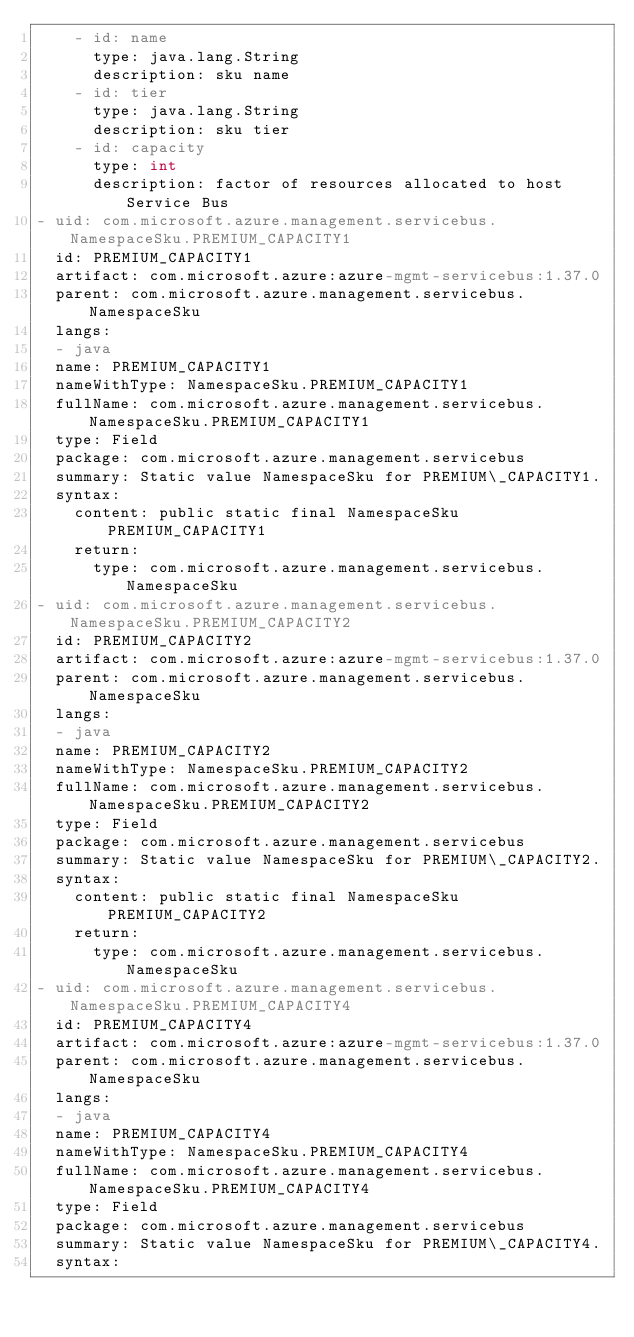Convert code to text. <code><loc_0><loc_0><loc_500><loc_500><_YAML_>    - id: name
      type: java.lang.String
      description: sku name
    - id: tier
      type: java.lang.String
      description: sku tier
    - id: capacity
      type: int
      description: factor of resources allocated to host Service Bus
- uid: com.microsoft.azure.management.servicebus.NamespaceSku.PREMIUM_CAPACITY1
  id: PREMIUM_CAPACITY1
  artifact: com.microsoft.azure:azure-mgmt-servicebus:1.37.0
  parent: com.microsoft.azure.management.servicebus.NamespaceSku
  langs:
  - java
  name: PREMIUM_CAPACITY1
  nameWithType: NamespaceSku.PREMIUM_CAPACITY1
  fullName: com.microsoft.azure.management.servicebus.NamespaceSku.PREMIUM_CAPACITY1
  type: Field
  package: com.microsoft.azure.management.servicebus
  summary: Static value NamespaceSku for PREMIUM\_CAPACITY1.
  syntax:
    content: public static final NamespaceSku PREMIUM_CAPACITY1
    return:
      type: com.microsoft.azure.management.servicebus.NamespaceSku
- uid: com.microsoft.azure.management.servicebus.NamespaceSku.PREMIUM_CAPACITY2
  id: PREMIUM_CAPACITY2
  artifact: com.microsoft.azure:azure-mgmt-servicebus:1.37.0
  parent: com.microsoft.azure.management.servicebus.NamespaceSku
  langs:
  - java
  name: PREMIUM_CAPACITY2
  nameWithType: NamespaceSku.PREMIUM_CAPACITY2
  fullName: com.microsoft.azure.management.servicebus.NamespaceSku.PREMIUM_CAPACITY2
  type: Field
  package: com.microsoft.azure.management.servicebus
  summary: Static value NamespaceSku for PREMIUM\_CAPACITY2.
  syntax:
    content: public static final NamespaceSku PREMIUM_CAPACITY2
    return:
      type: com.microsoft.azure.management.servicebus.NamespaceSku
- uid: com.microsoft.azure.management.servicebus.NamespaceSku.PREMIUM_CAPACITY4
  id: PREMIUM_CAPACITY4
  artifact: com.microsoft.azure:azure-mgmt-servicebus:1.37.0
  parent: com.microsoft.azure.management.servicebus.NamespaceSku
  langs:
  - java
  name: PREMIUM_CAPACITY4
  nameWithType: NamespaceSku.PREMIUM_CAPACITY4
  fullName: com.microsoft.azure.management.servicebus.NamespaceSku.PREMIUM_CAPACITY4
  type: Field
  package: com.microsoft.azure.management.servicebus
  summary: Static value NamespaceSku for PREMIUM\_CAPACITY4.
  syntax:</code> 